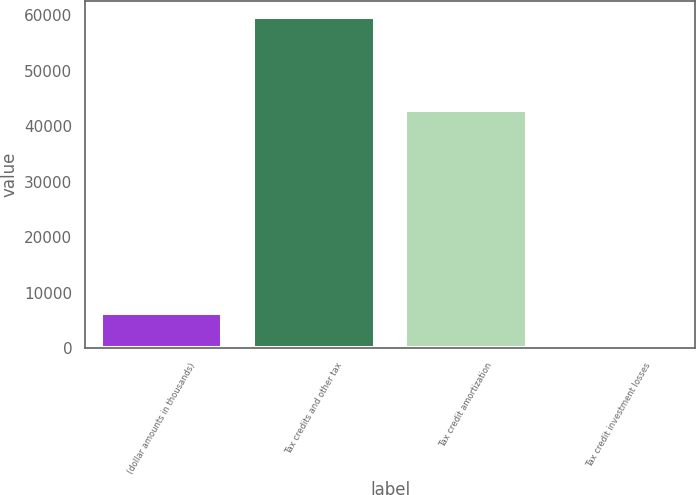Convert chart to OTSL. <chart><loc_0><loc_0><loc_500><loc_500><bar_chart><fcel>(dollar amounts in thousands)<fcel>Tax credits and other tax<fcel>Tax credit amortization<fcel>Tax credit investment losses<nl><fcel>6280.9<fcel>59614<fcel>42951<fcel>355<nl></chart> 